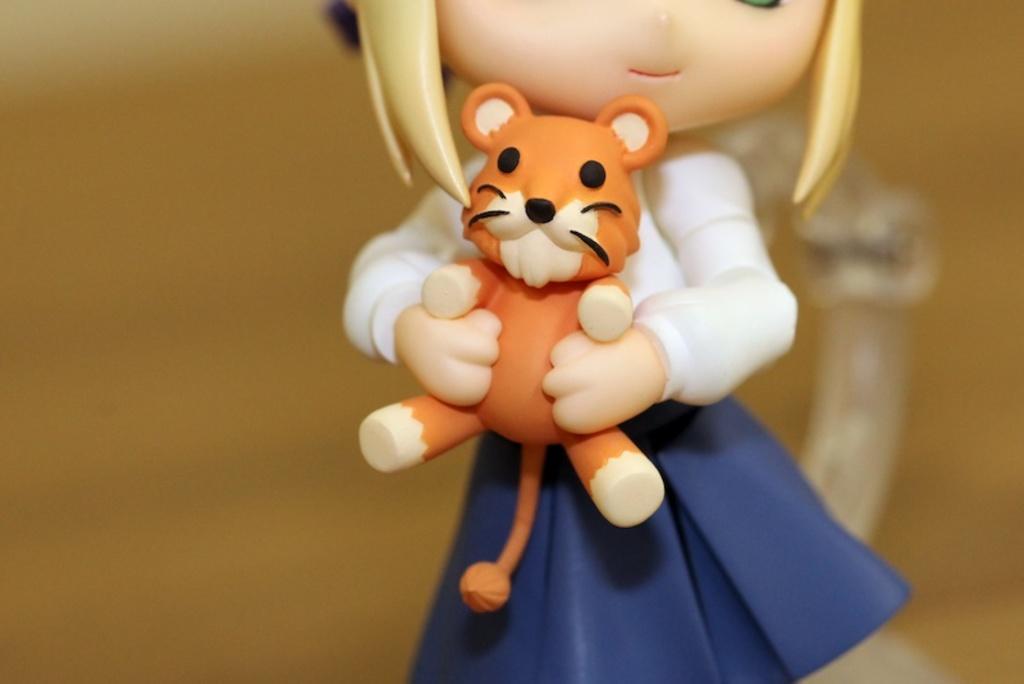Could you give a brief overview of what you see in this image? In this picture we can see there are toys. Behind the toys, there is the blurred background. 